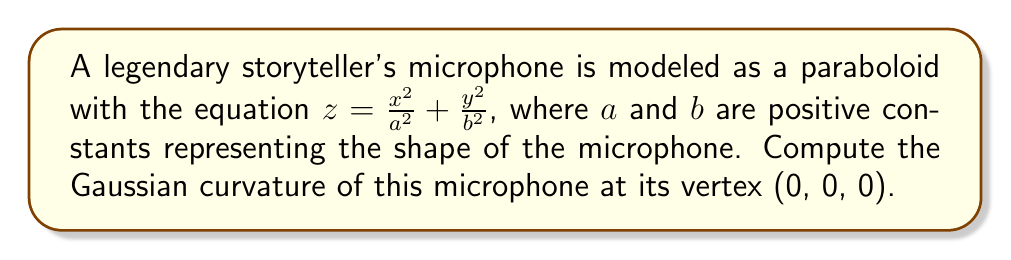Can you answer this question? To compute the Gaussian curvature of the paraboloid at its vertex, we'll follow these steps:

1) The Gaussian curvature K is given by $K = \frac{LN - M^2}{EG - F^2}$, where E, F, G are the coefficients of the first fundamental form, and L, M, N are the coefficients of the second fundamental form.

2) For a surface given by $z = f(x,y)$, we have:
   $E = 1 + f_x^2$, $F = f_x f_y$, $G = 1 + f_y^2$
   $L = \frac{f_{xx}}{\sqrt{1 + f_x^2 + f_y^2}}$, $M = \frac{f_{xy}}{\sqrt{1 + f_x^2 + f_y^2}}$, $N = \frac{f_{yy}}{\sqrt{1 + f_x^2 + f_y^2}}$

3) For our paraboloid, $f(x,y) = \frac{x^2}{a^2} + \frac{y^2}{b^2}$

4) Calculate partial derivatives:
   $f_x = \frac{2x}{a^2}$, $f_y = \frac{2y}{b^2}$
   $f_{xx} = \frac{2}{a^2}$, $f_{yy} = \frac{2}{b^2}$, $f_{xy} = 0$

5) At the vertex (0, 0, 0):
   $f_x = f_y = 0$
   $E = G = 1$, $F = 0$
   $L = \frac{2}{a^2}$, $N = \frac{2}{b^2}$, $M = 0$

6) Substitute into the Gaussian curvature formula:
   $K = \frac{LN - M^2}{EG - F^2} = \frac{(\frac{2}{a^2})(\frac{2}{b^2}) - 0^2}{1 \cdot 1 - 0^2} = \frac{4}{a^2b^2}$

Therefore, the Gaussian curvature at the vertex of the microphone is $\frac{4}{a^2b^2}$.
Answer: $\frac{4}{a^2b^2}$ 